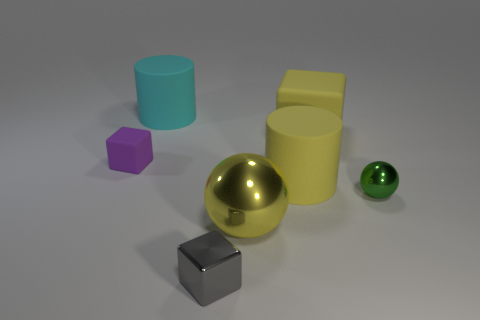Add 3 small blocks. How many objects exist? 10 Subtract all balls. How many objects are left? 5 Subtract all tiny brown blocks. Subtract all yellow cylinders. How many objects are left? 6 Add 3 tiny metallic objects. How many tiny metallic objects are left? 5 Add 5 metal balls. How many metal balls exist? 7 Subtract 1 yellow cylinders. How many objects are left? 6 